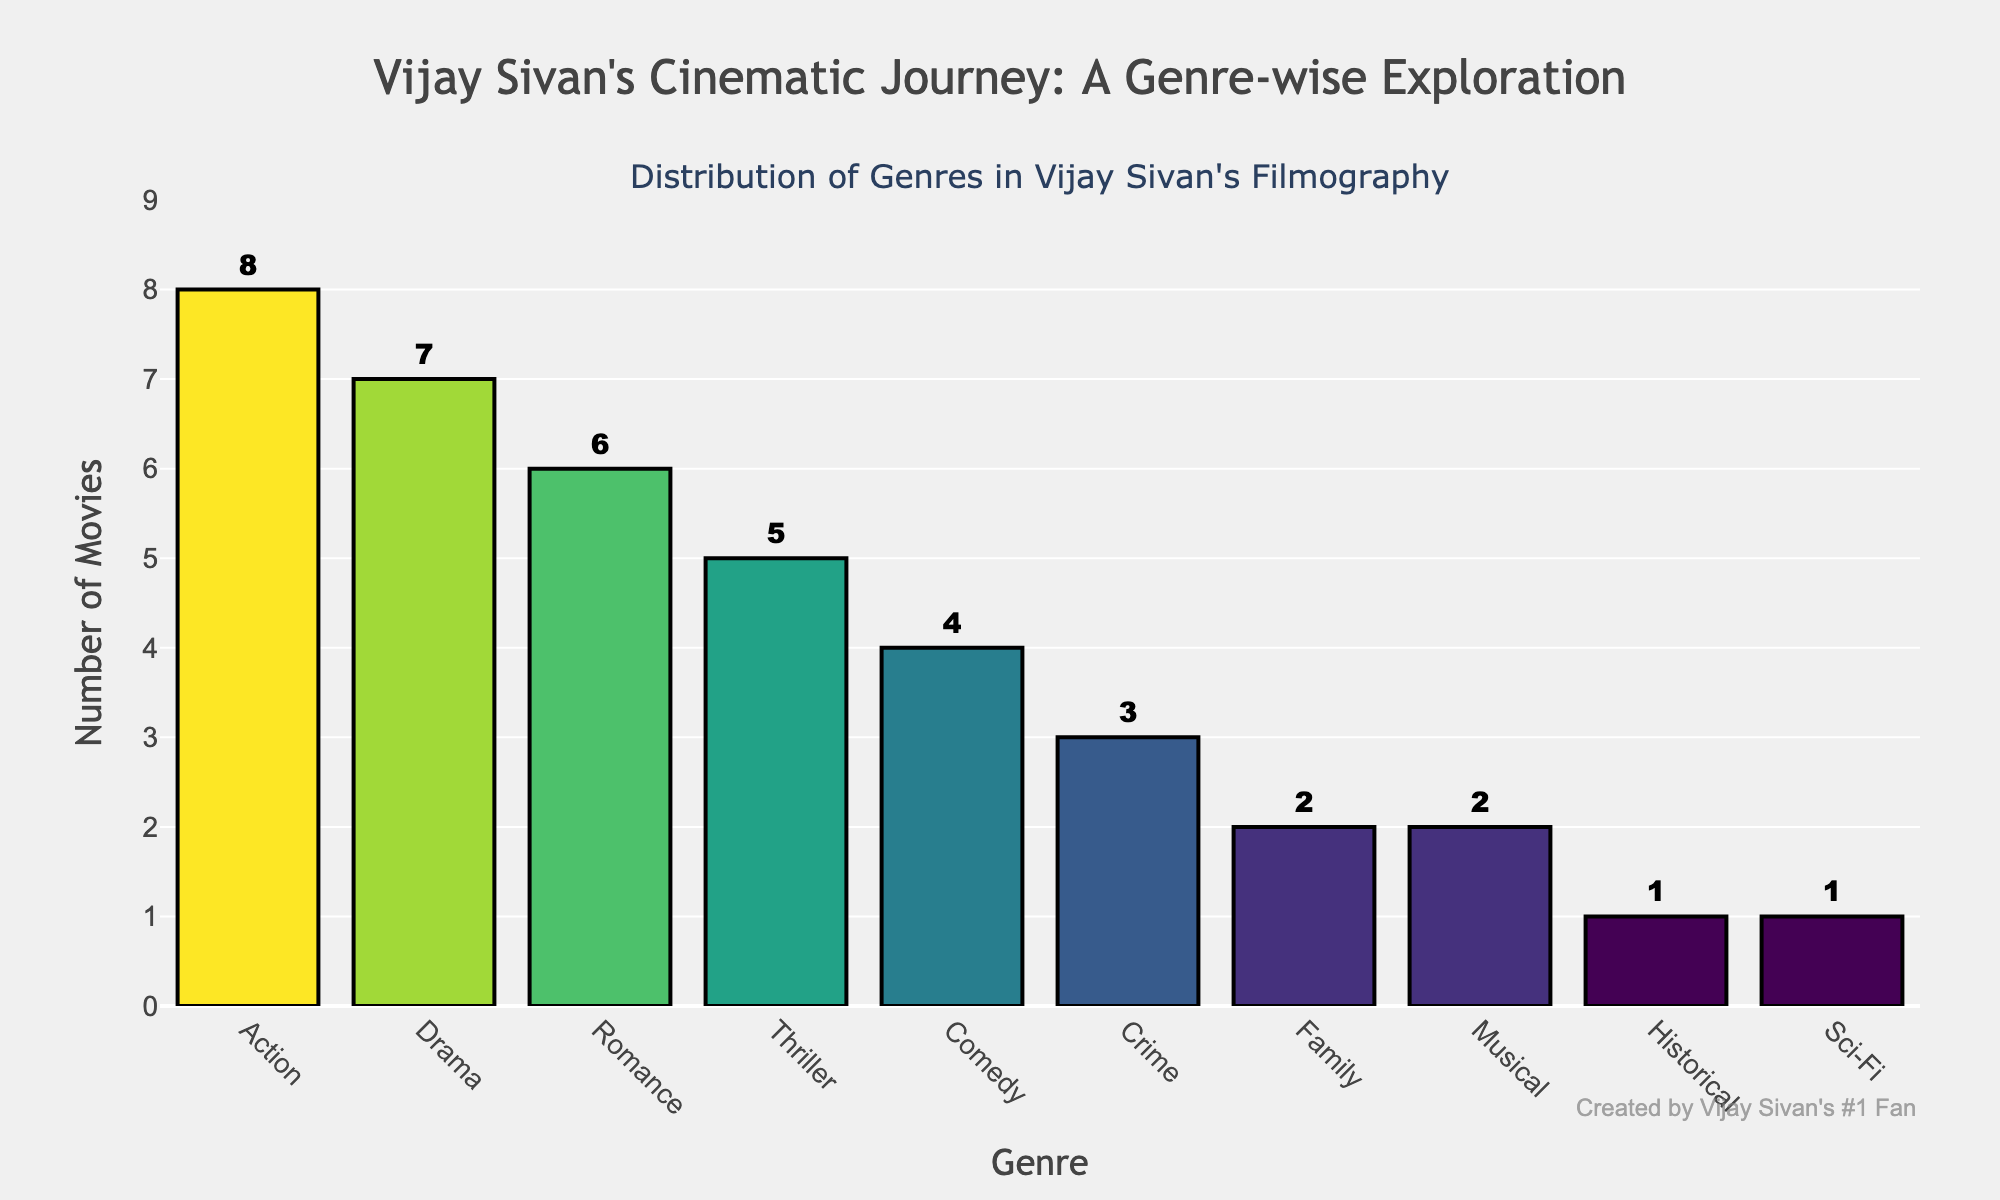What genre has the most number of movies? The highest bar in the chart represents the Action genre.
Answer: Action How many more Action movies are there compared to Historical movies? The number of Action movies is 8, and the number of Historical movies is 1. The difference is 8 - 1 = 7.
Answer: 7 Which genre has the second most number of movies? The second tallest bar in the chart represents Drama with 7 movies.
Answer: Drama What's the total number of Romance and Comedy movies? There are 6 Romance movies and 4 Comedy movies. The total is 6 + 4 = 10.
Answer: 10 How many genres have a number of movies equal to or greater than 5? Action (8), Romance (6), Thriller (5), and Drama (7) are equal to or greater than 5. The count is 4 genres.
Answer: 4 Is the number of Drama movies greater than the number of Thriller movies? There are 7 Drama movies and 5 Thriller movies. 7 is greater than 5.
Answer: Yes What's the average number of movies in the Crime, Family, and Historical genres? The number of movies for Crime is 3, Family is 2, and Historical is 1. The average is (3 + 2 + 1) / 3 = 2.
Answer: 2 What is the total number of movies represented in the chart? Add all the numbers: 8 (Action) + 6 (Romance) + 5 (Thriller) + 7 (Drama) + 4 (Comedy) + 3 (Crime) + 2 (Family) + 1 (Historical) + 1 (Sci-Fi) + 2 (Musical) = 39.
Answer: 39 Is there an equal number of Musical and Family movies? The chart shows that both Musical and Family genres have 2 movies each.
Answer: Yes 